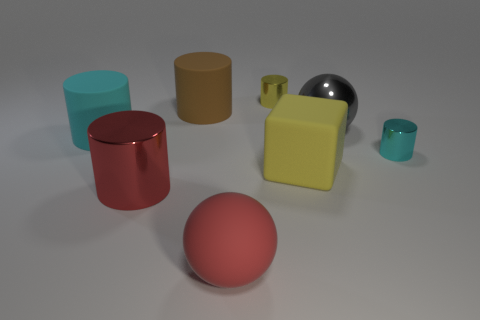Subtract all large cylinders. How many cylinders are left? 2 Subtract 1 spheres. How many spheres are left? 1 Subtract all red balls. How many balls are left? 1 Add 1 large cyan rubber objects. How many objects exist? 9 Add 5 large cyan cylinders. How many large cyan cylinders are left? 6 Add 8 large cyan things. How many large cyan things exist? 9 Subtract 0 brown cubes. How many objects are left? 8 Subtract all balls. How many objects are left? 6 Subtract all brown cylinders. Subtract all gray cubes. How many cylinders are left? 4 Subtract all red cubes. How many green balls are left? 0 